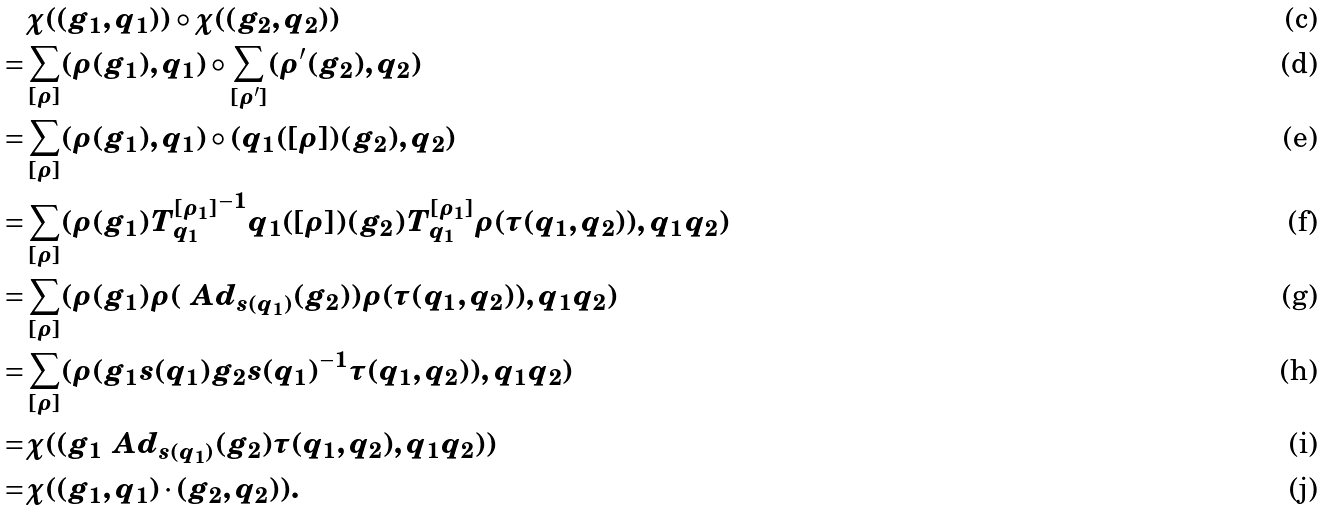Convert formula to latex. <formula><loc_0><loc_0><loc_500><loc_500>& \chi ( ( g _ { 1 } , q _ { 1 } ) ) \circ \chi ( ( g _ { 2 } , q _ { 2 } ) ) \\ = & \sum _ { [ \rho ] } ( \rho ( g _ { 1 } ) , q _ { 1 } ) \circ \sum _ { [ \rho ^ { \prime } ] } ( \rho ^ { \prime } ( g _ { 2 } ) , q _ { 2 } ) \\ = & \sum _ { [ \rho ] } ( \rho ( g _ { 1 } ) , q _ { 1 } ) \circ ( q _ { 1 } ( [ \rho ] ) ( g _ { 2 } ) , q _ { 2 } ) \\ = & \sum _ { [ \rho ] } ( \rho ( g _ { 1 } ) { T ^ { [ \rho _ { 1 } ] } _ { q _ { 1 } } } ^ { - 1 } q _ { 1 } ( [ \rho ] ) ( g _ { 2 } ) T ^ { [ \rho _ { 1 } ] } _ { q _ { 1 } } \rho ( \tau ( q _ { 1 } , q _ { 2 } ) ) , q _ { 1 } q _ { 2 } ) \\ = & \sum _ { [ \rho ] } ( \rho ( g _ { 1 } ) \rho ( \ A d _ { s ( q _ { 1 } ) } ( g _ { 2 } ) ) \rho ( \tau ( q _ { 1 } , q _ { 2 } ) ) , q _ { 1 } q _ { 2 } ) \\ = & \sum _ { [ \rho ] } ( \rho ( g _ { 1 } s ( q _ { 1 } ) g _ { 2 } s ( q _ { 1 } ) ^ { - 1 } \tau ( q _ { 1 } , q _ { 2 } ) ) , q _ { 1 } q _ { 2 } ) \\ = & \chi ( ( g _ { 1 } \ A d _ { s ( q _ { 1 } ) } ( g _ { 2 } ) \tau ( q _ { 1 } , q _ { 2 } ) , q _ { 1 } q _ { 2 } ) ) \\ = & \chi ( ( g _ { 1 } , q _ { 1 } ) \cdot ( g _ { 2 } , q _ { 2 } ) ) .</formula> 